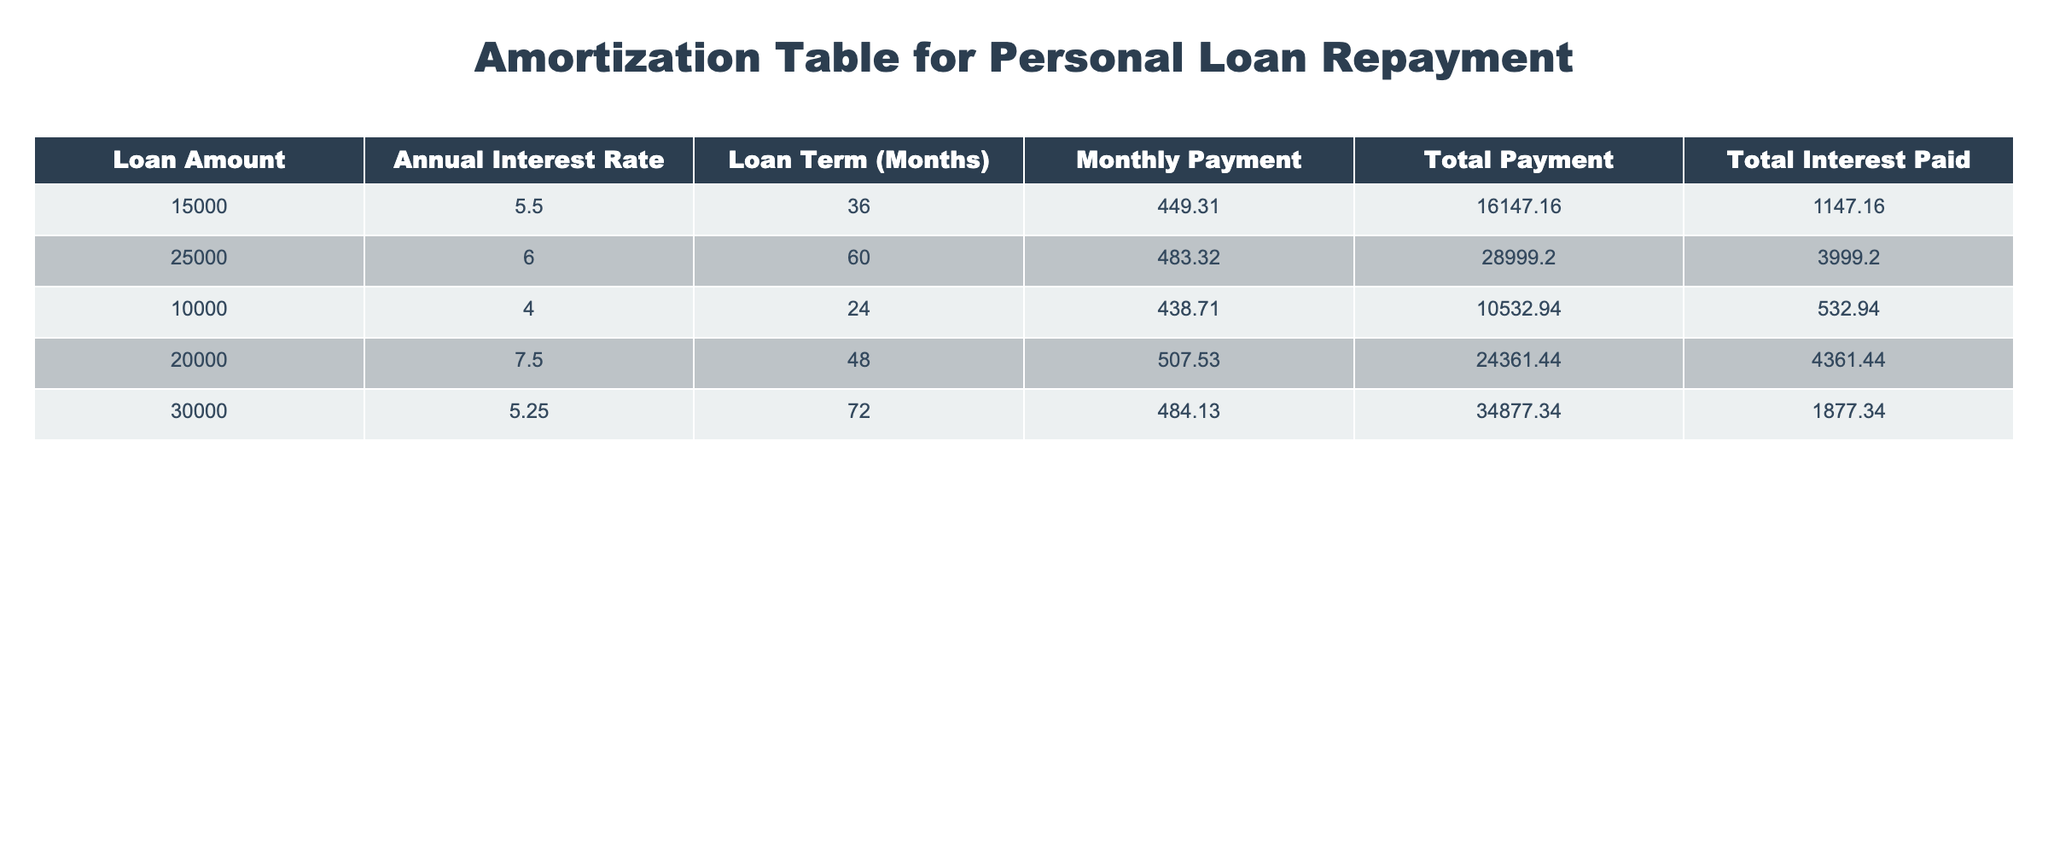What is the loan amount for the loan with the highest total interest paid? The row with the highest total interest paid is the one with the loan amount of 20000, which has a total interest paid of 4361.44. Thus, the loan amount is 20000.
Answer: 20000 How many months is the loan term for the loan with the lowest monthly payment? The row with the lowest monthly payment is the one with the loan amount of 10000, and it has a loan term of 24 months. Thus, the loan term is 24 months.
Answer: 24 months What is the difference between the highest and lowest monthly payment? The highest monthly payment is 507.53 for the loan amount of 20000, and the lowest monthly payment is 438.71 for the loan amount of 10000. The difference is 507.53 - 438.71 = 68.82.
Answer: 68.82 Is the total payment for the loan amount of 30000 less than 35000? The total payment for the loan amount of 30000 is 34877.34, which is indeed less than 35000. Thus, the statement is true.
Answer: Yes What is the average total interest paid across all loans in the table? To find the average total interest paid, we first sum the total interest values: 1147.16 + 3999.20 + 532.94 + 4361.44 + 1877.34 = 12918.08. Then, we divide by the number of loans (5): 12918.08 / 5 = 2583.616.
Answer: 2583.62 Which loan has the longest term, and what is its monthly payment? The longest loan term is 72 months, corresponding to the loan amount of 30000. The monthly payment for this loan is 484.13.
Answer: 484.13 Is there any loan with an annual interest rate of 5% or lower? Checking the table, the lowest annual interest rate listed is 4.0 for the loan amount of 10000. Thus, there is a loan with an interest rate of 5% or lower, making the statement true.
Answer: Yes What percentage of the total payment is the total interest paid for the loan amount of 25000? The total payment for the loan amount of 25000 is 28999.20, and the total interest paid is 3999.20. The percentage is calculated as (3999.20 / 28999.20) * 100 = 13.79% (approx).
Answer: 13.79% 